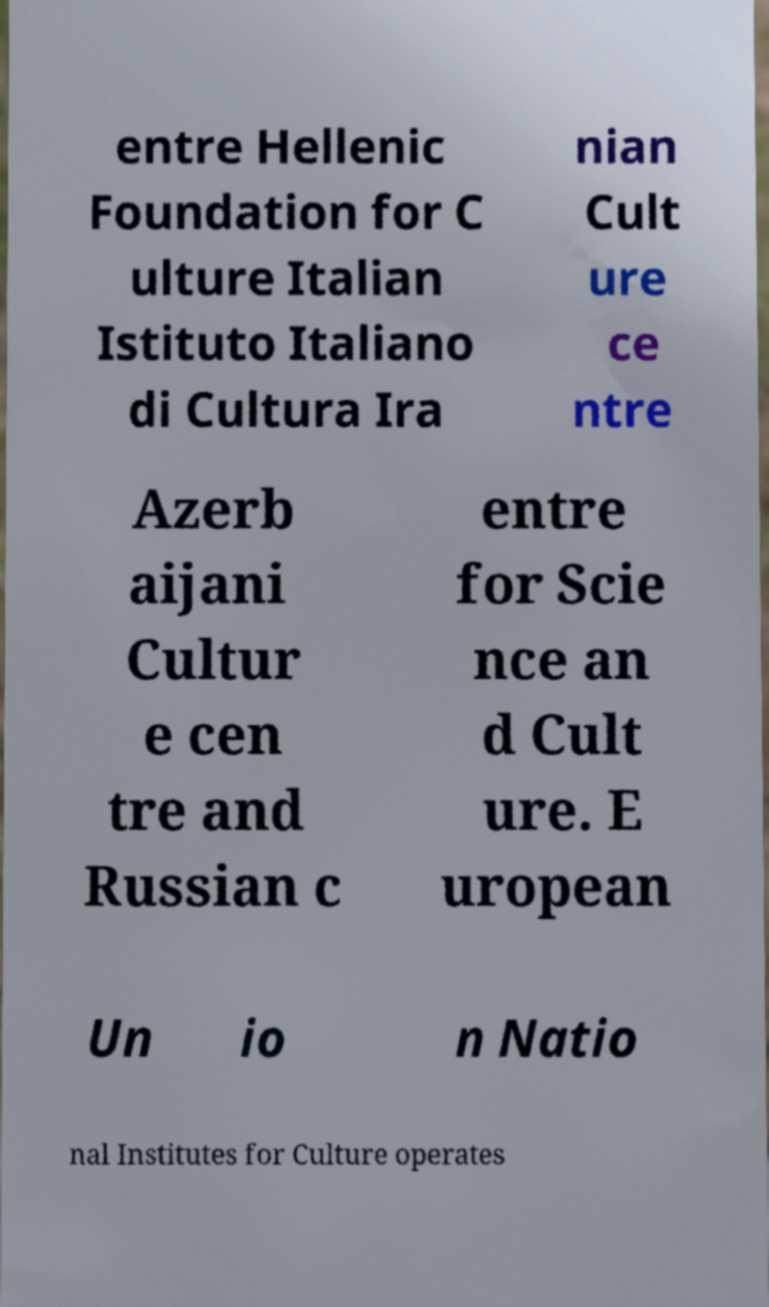Please read and relay the text visible in this image. What does it say? entre Hellenic Foundation for C ulture Italian Istituto Italiano di Cultura Ira nian Cult ure ce ntre Azerb aijani Cultur e cen tre and Russian c entre for Scie nce an d Cult ure. E uropean Un io n Natio nal Institutes for Culture operates 